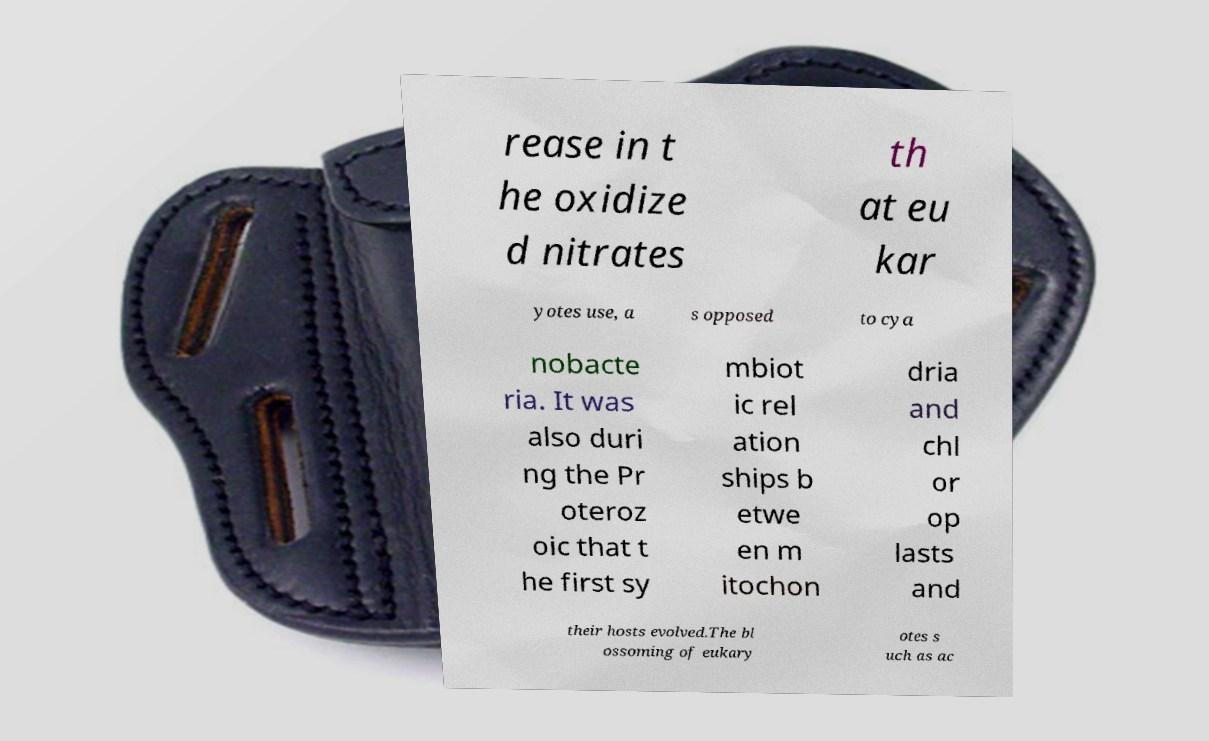Can you accurately transcribe the text from the provided image for me? rease in t he oxidize d nitrates th at eu kar yotes use, a s opposed to cya nobacte ria. It was also duri ng the Pr oteroz oic that t he first sy mbiot ic rel ation ships b etwe en m itochon dria and chl or op lasts and their hosts evolved.The bl ossoming of eukary otes s uch as ac 